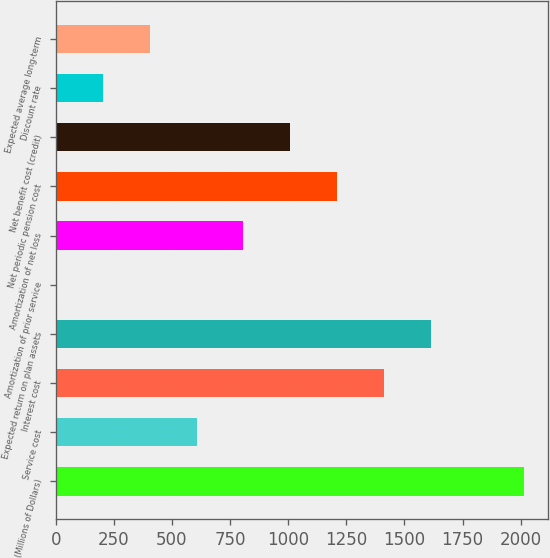Convert chart. <chart><loc_0><loc_0><loc_500><loc_500><bar_chart><fcel>(Millions of Dollars)<fcel>Service cost<fcel>Interest cost<fcel>Expected return on plan assets<fcel>Amortization of prior service<fcel>Amortization of net loss<fcel>Net periodic pension cost<fcel>Net benefit cost (credit)<fcel>Discount rate<fcel>Expected average long-term<nl><fcel>2016<fcel>606.2<fcel>1411.8<fcel>1613.2<fcel>2<fcel>807.6<fcel>1210.4<fcel>1009<fcel>203.4<fcel>404.8<nl></chart> 